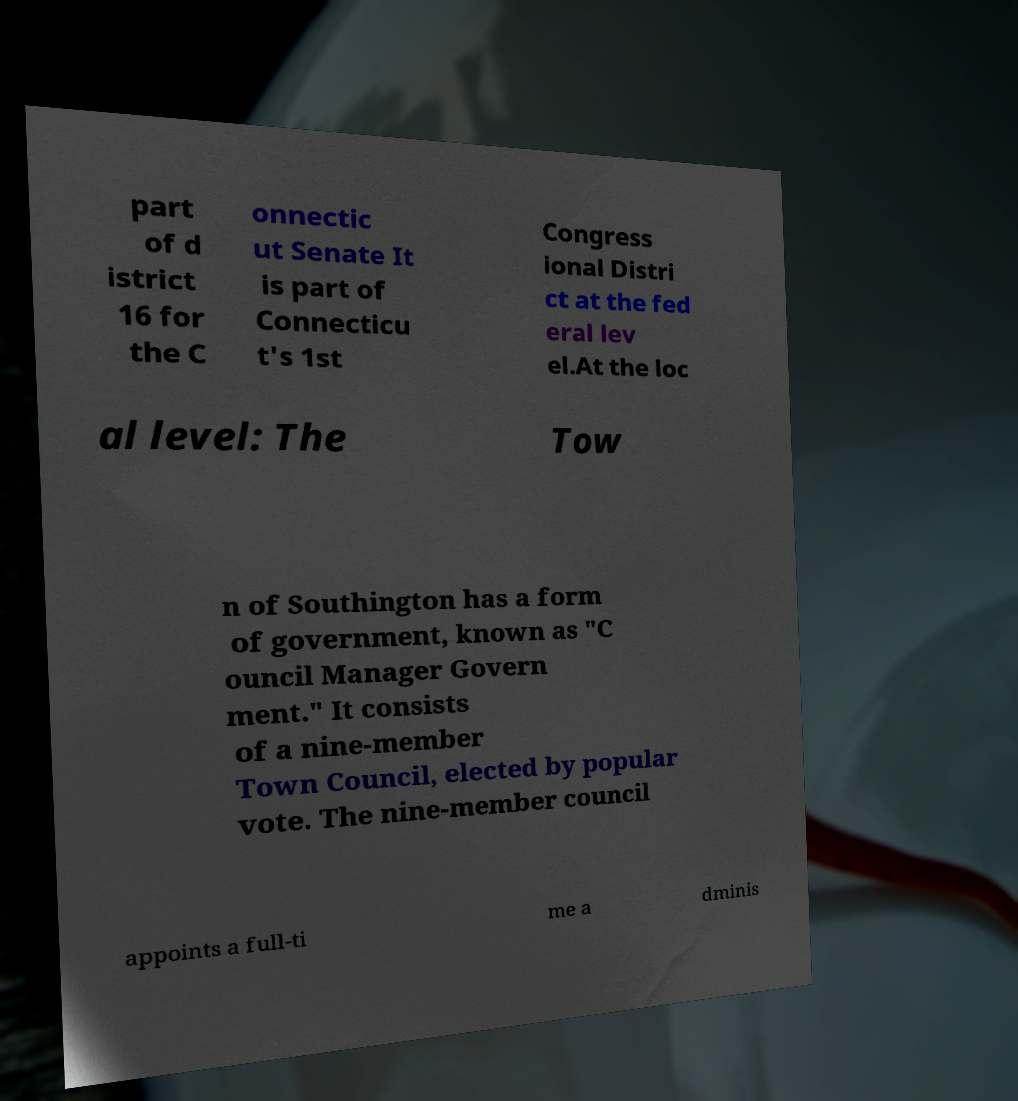Could you assist in decoding the text presented in this image and type it out clearly? part of d istrict 16 for the C onnectic ut Senate It is part of Connecticu t's 1st Congress ional Distri ct at the fed eral lev el.At the loc al level: The Tow n of Southington has a form of government, known as "C ouncil Manager Govern ment." It consists of a nine-member Town Council, elected by popular vote. The nine-member council appoints a full-ti me a dminis 